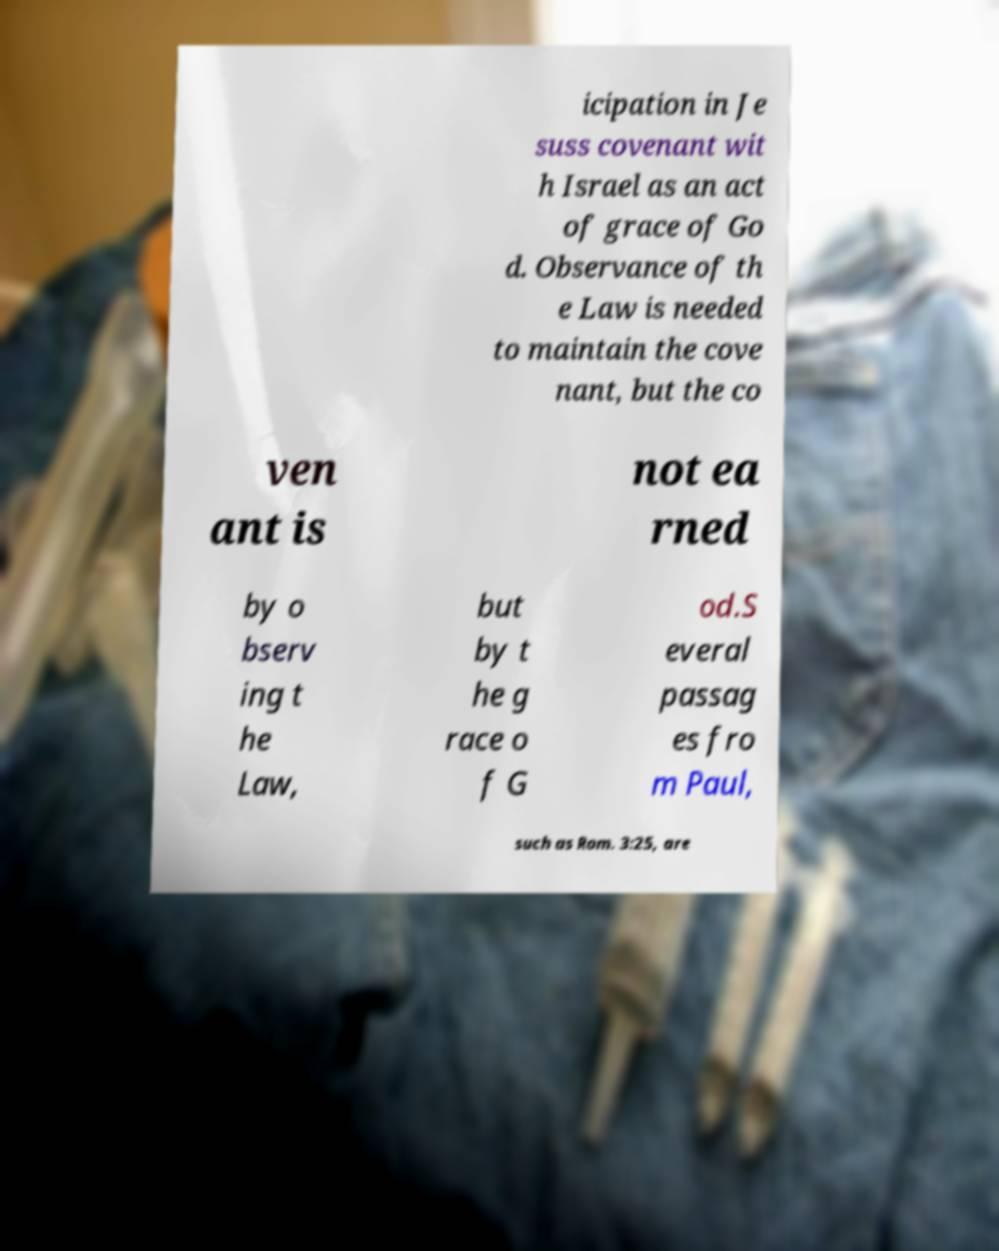There's text embedded in this image that I need extracted. Can you transcribe it verbatim? icipation in Je suss covenant wit h Israel as an act of grace of Go d. Observance of th e Law is needed to maintain the cove nant, but the co ven ant is not ea rned by o bserv ing t he Law, but by t he g race o f G od.S everal passag es fro m Paul, such as Rom. 3:25, are 